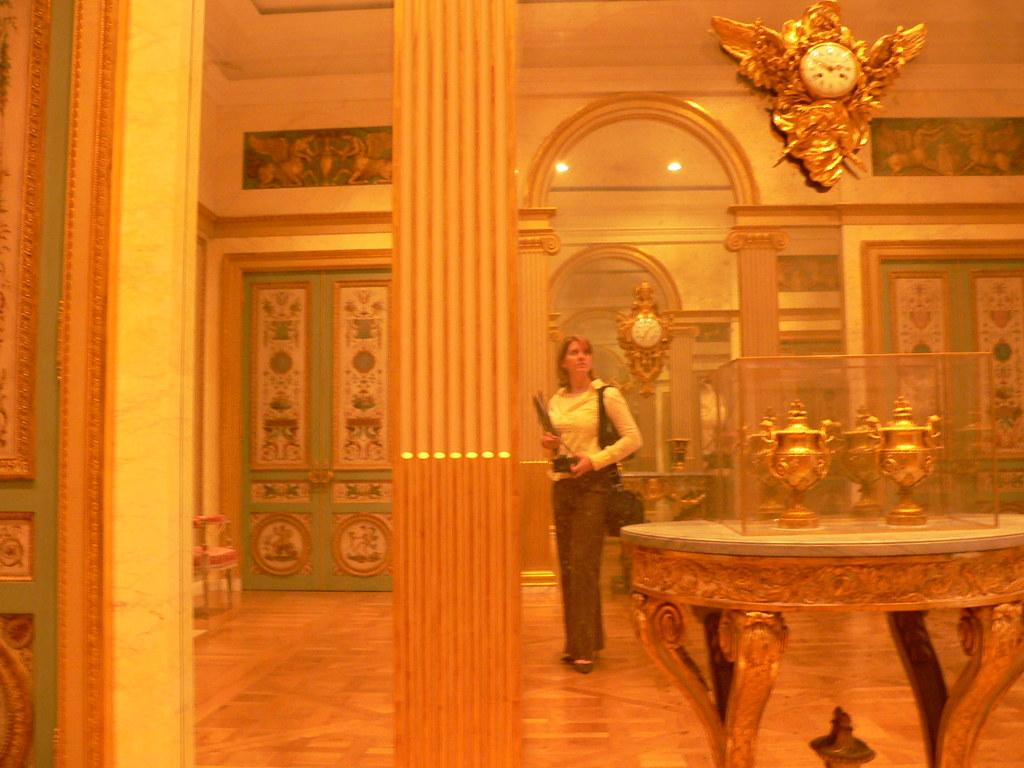Where is the image taken? The image is taken in a room. What can be seen in the room? There is a woman standing in the room. What is the woman standing on? The woman is standing on a floor. Can you describe any objects or details in the room? There is a glass with a reflection of a clock behind the woman. What type of dock can be seen in the image? There is no dock present in the image; it is taken in a room with a woman standing in it. 